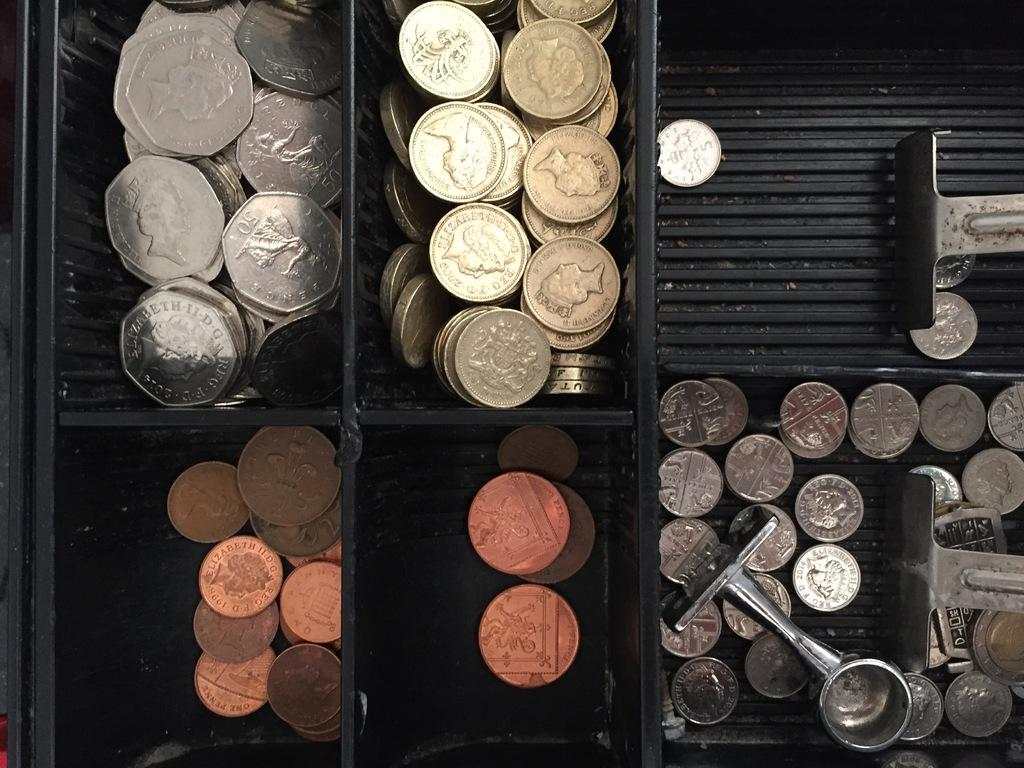<image>
Create a compact narrative representing the image presented. A drawerful of foreign coins, including some copper ones that say pence. 